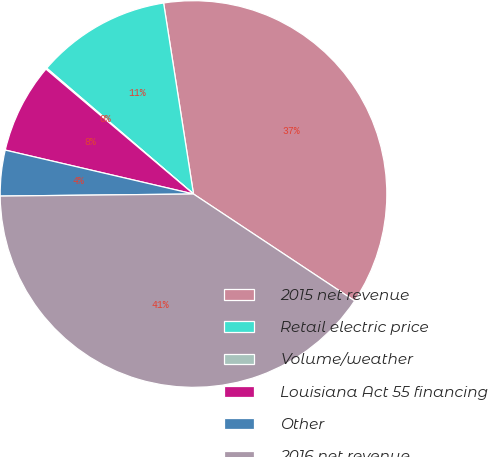<chart> <loc_0><loc_0><loc_500><loc_500><pie_chart><fcel>2015 net revenue<fcel>Retail electric price<fcel>Volume/weather<fcel>Louisiana Act 55 financing<fcel>Other<fcel>2016 net revenue<nl><fcel>36.79%<fcel>11.25%<fcel>0.1%<fcel>7.53%<fcel>3.82%<fcel>40.51%<nl></chart> 